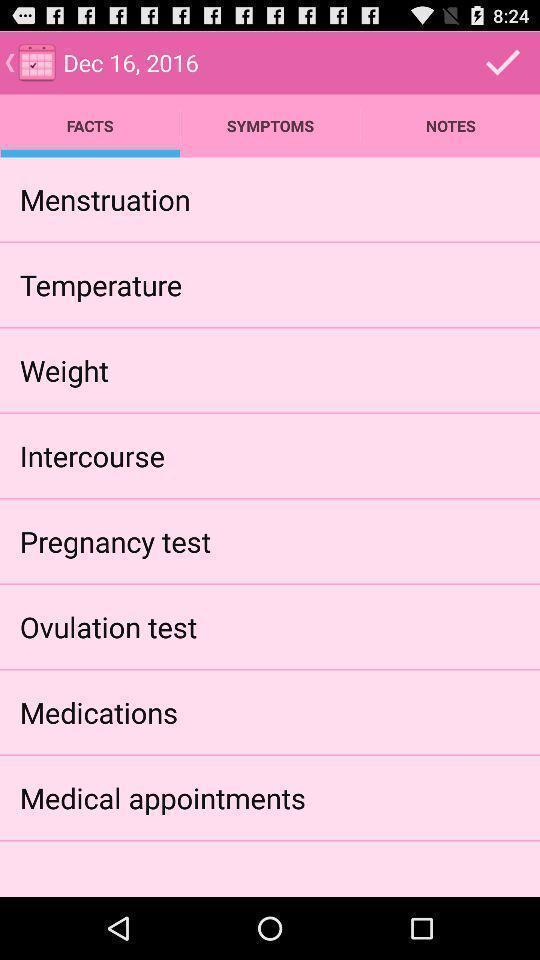Explain what's happening in this screen capture. Screen showing list of various options of a health app. 